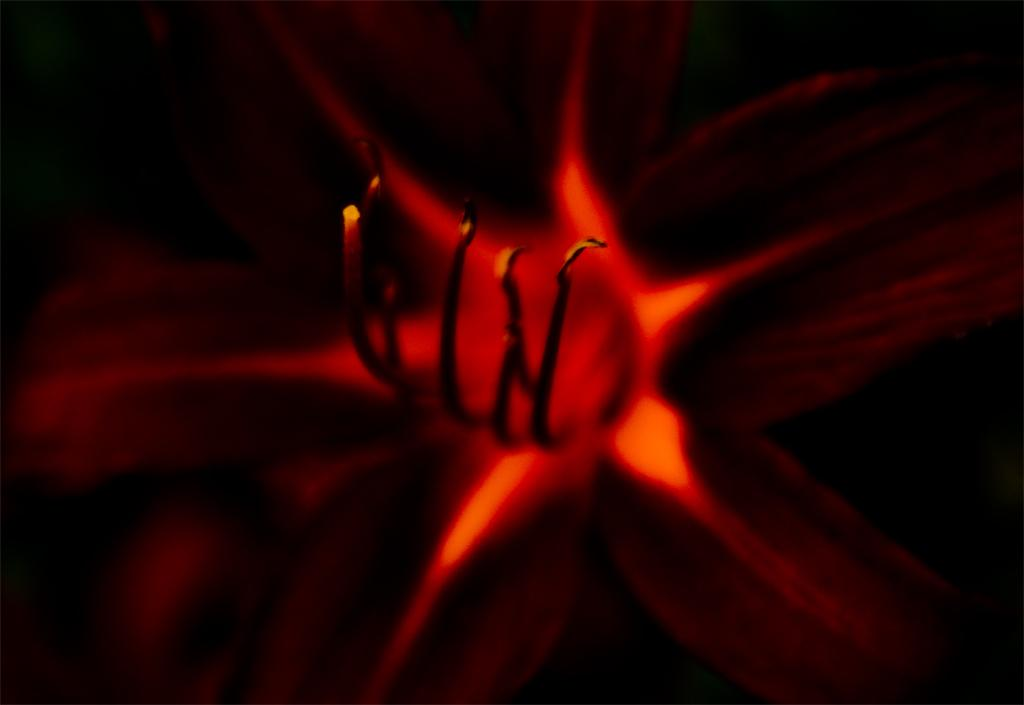What is the main subject of the image? There is a flower in the image. Can you describe the colors of the flower? The flower has black, brown, and red colors. What is the color of the background in the image? The background of the image is black. What type of pan can be seen hanging from the flower in the image? There is no pan present in the image, and the flower is not holding or supporting any objects. 